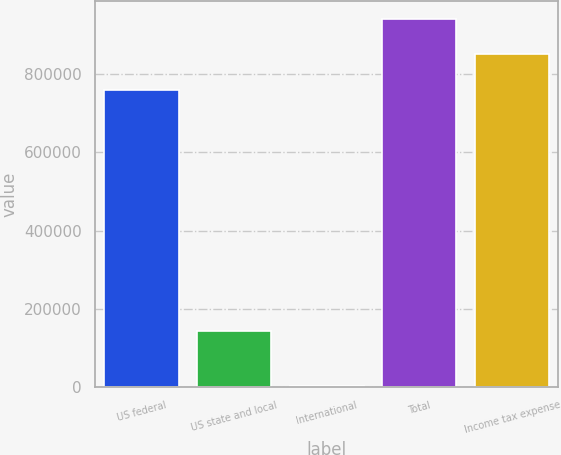Convert chart to OTSL. <chart><loc_0><loc_0><loc_500><loc_500><bar_chart><fcel>US federal<fcel>US state and local<fcel>International<fcel>Total<fcel>Income tax expense<nl><fcel>759683<fcel>143610<fcel>3415<fcel>940342<fcel>850012<nl></chart> 